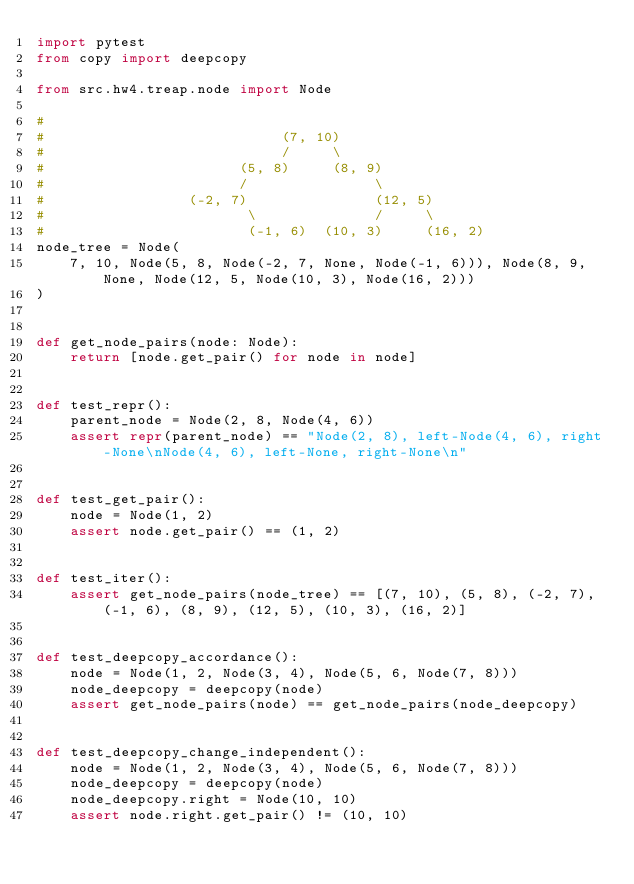<code> <loc_0><loc_0><loc_500><loc_500><_Python_>import pytest
from copy import deepcopy

from src.hw4.treap.node import Node

#
#                            (7, 10)
#                            /     \
#                       (5, 8)     (8, 9)
#                       /               \
#                 (-2, 7)               (12, 5)
#                        \              /     \
#                        (-1, 6)  (10, 3)     (16, 2)
node_tree = Node(
    7, 10, Node(5, 8, Node(-2, 7, None, Node(-1, 6))), Node(8, 9, None, Node(12, 5, Node(10, 3), Node(16, 2)))
)


def get_node_pairs(node: Node):
    return [node.get_pair() for node in node]


def test_repr():
    parent_node = Node(2, 8, Node(4, 6))
    assert repr(parent_node) == "Node(2, 8), left-Node(4, 6), right-None\nNode(4, 6), left-None, right-None\n"


def test_get_pair():
    node = Node(1, 2)
    assert node.get_pair() == (1, 2)


def test_iter():
    assert get_node_pairs(node_tree) == [(7, 10), (5, 8), (-2, 7), (-1, 6), (8, 9), (12, 5), (10, 3), (16, 2)]


def test_deepcopy_accordance():
    node = Node(1, 2, Node(3, 4), Node(5, 6, Node(7, 8)))
    node_deepcopy = deepcopy(node)
    assert get_node_pairs(node) == get_node_pairs(node_deepcopy)


def test_deepcopy_change_independent():
    node = Node(1, 2, Node(3, 4), Node(5, 6, Node(7, 8)))
    node_deepcopy = deepcopy(node)
    node_deepcopy.right = Node(10, 10)
    assert node.right.get_pair() != (10, 10)
</code> 